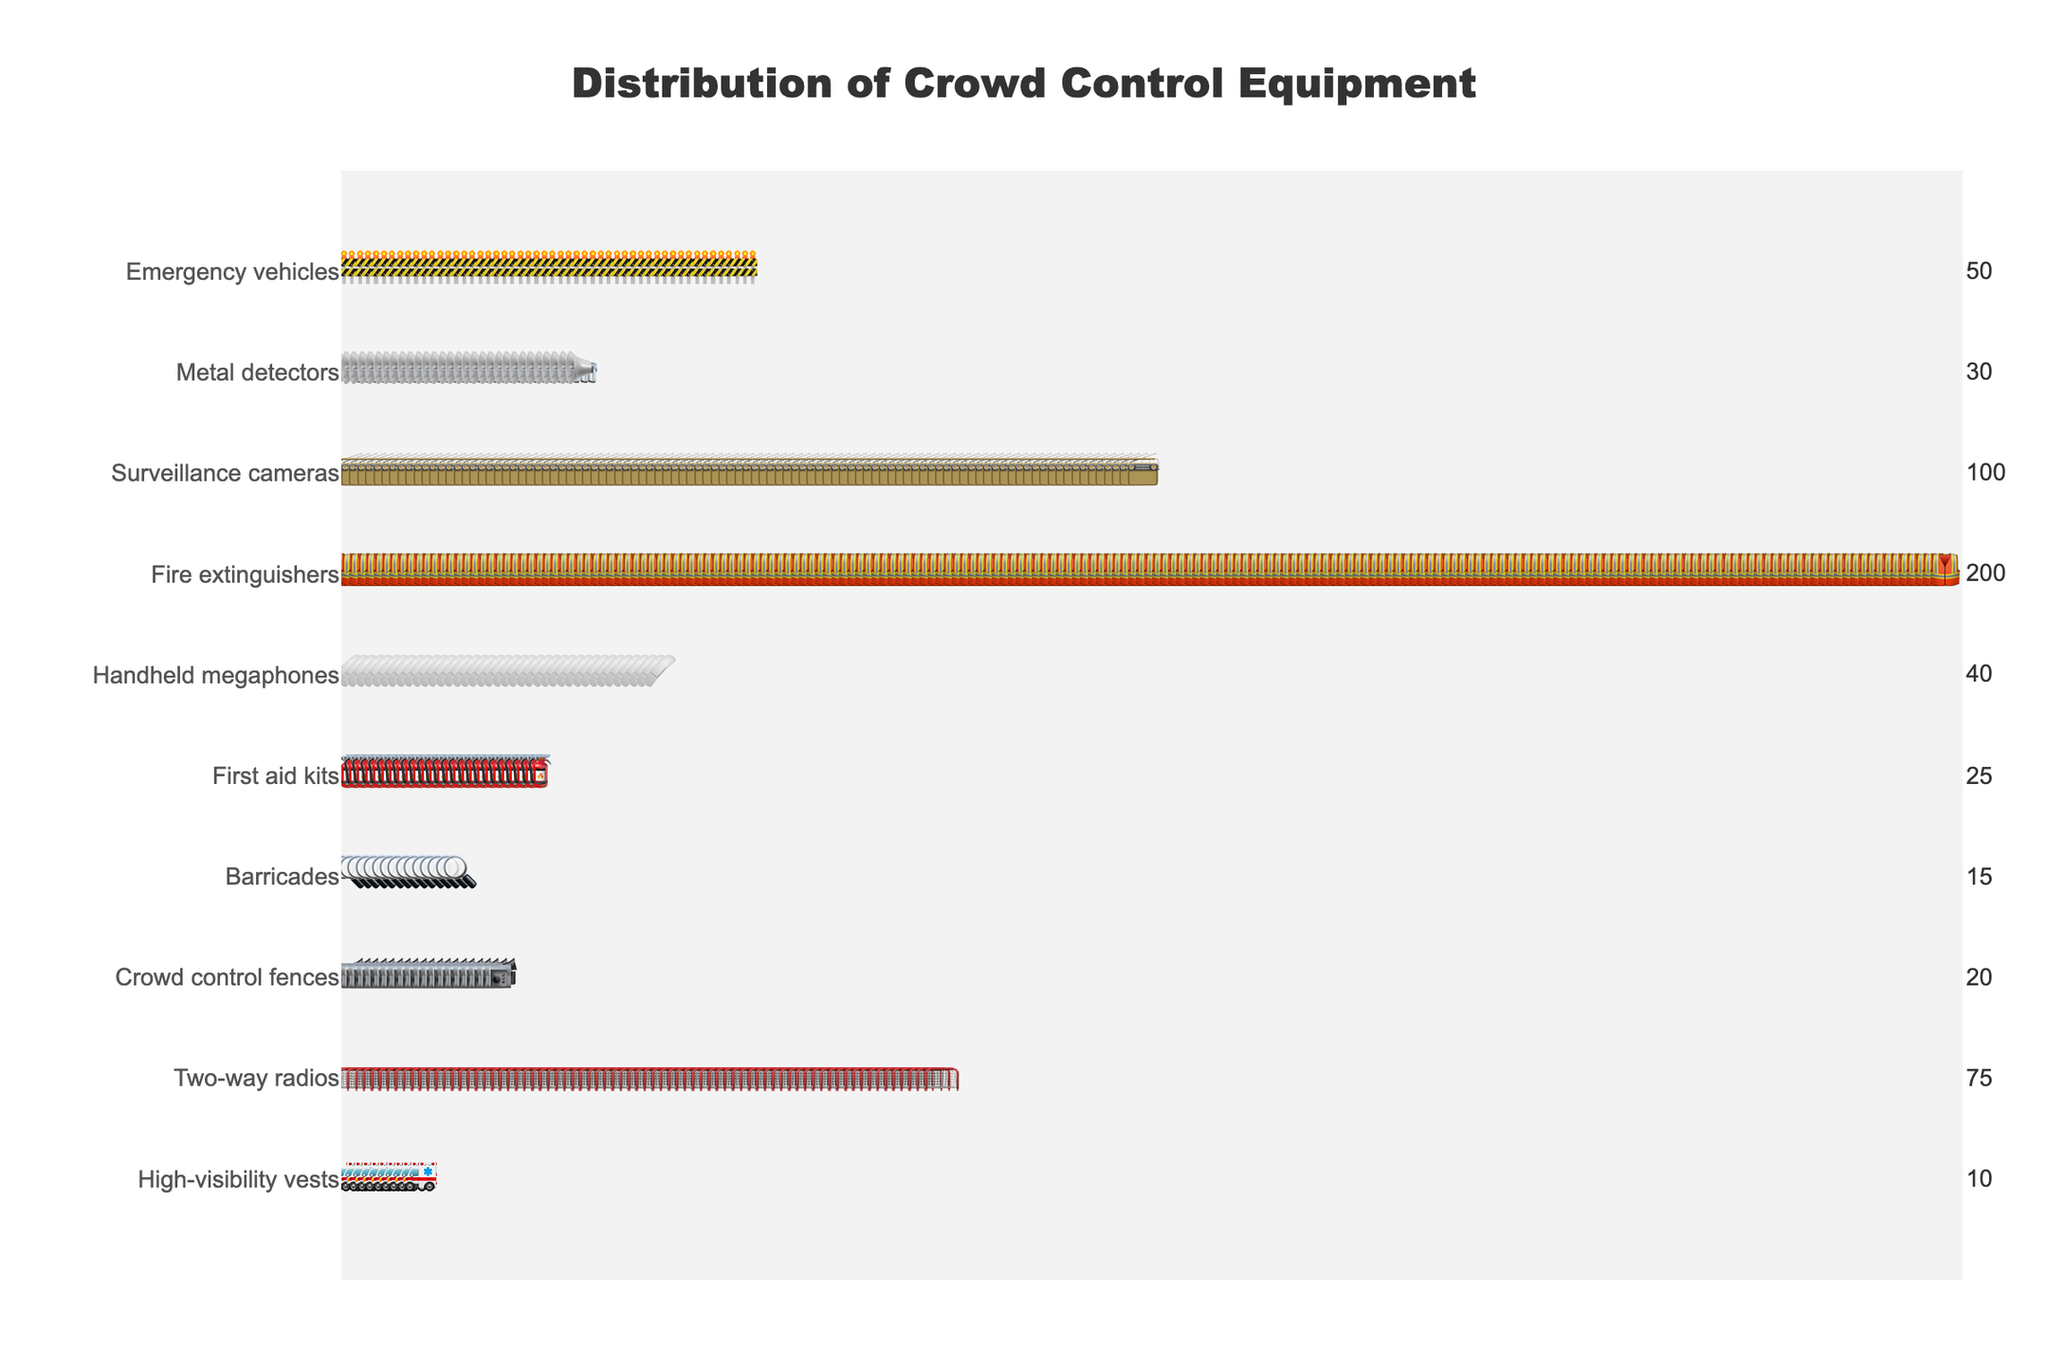What's the title of the figure? The title is usually displayed at the top of the figure. Here it is indicated by 'Distribution of Crowd Control Equipment'.
Answer: Distribution of Crowd Control Equipment Which equipment type has the largest count? The equipment type with the largest count will have the most icons in the figure. Here, 'High-visibility vests' have the highest count.
Answer: High-visibility vests How many surveillance cameras are there? Look for the row labeled 'Surveillance cameras' and count the number of 📹 icons. The annotation on the right also shows the count.
Answer: 20 What is the combined count of Fire extinguishers and First aid kits? Find the individual counts for 'Fire extinguishers' (25) and 'First aid kits' (40) and sum them up: 25 + 40.
Answer: 65 Which equipment type has fewer items: Metal detectors or Emergency vehicles? Compare the counts of 'Metal detectors' (15) and 'Emergency vehicles' (10), and see which is smaller.
Answer: Emergency vehicles Which two equipment types have counts that differ by exactly 10? Identify the counts and check the differences: 'Handheld megaphones' (30) and 'First aid kits' (40) differ by exactly 10 (40 - 30).
Answer: Handheld megaphones and First aid kits How many more Two-way radios are there compared to Barricades? Subtract the count of 'Barricades' (50) from 'Two-way radios' (100): 100 - 50.
Answer: 50 What is the average count of Crowd control fences and Barricades? Add the counts (75 for 'Crowd control fences' and 50 for 'Barricades') and then divide by 2: (75 + 50) / 2.
Answer: 62.5 Are there more Handheld megaphones or Surveillance cameras? Compare the counts: 'Handheld megaphones' (30) and 'Surveillance cameras' (20). Handheld megaphones have a larger count.
Answer: Handheld megaphones What is the median count of all equipment types listed? Sort the counts in ascending order [10, 15, 20, 25, 30, 40, 50, 75, 100, 200] and find the median value. Since there are 10 items, the median is the average of the 5th and 6th values: (30 + 40) / 2.
Answer: 35 